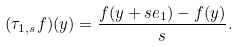<formula> <loc_0><loc_0><loc_500><loc_500>( \tau _ { 1 , s } f ) ( y ) = \frac { f ( y + s e _ { 1 } ) - f ( y ) } { s } .</formula> 